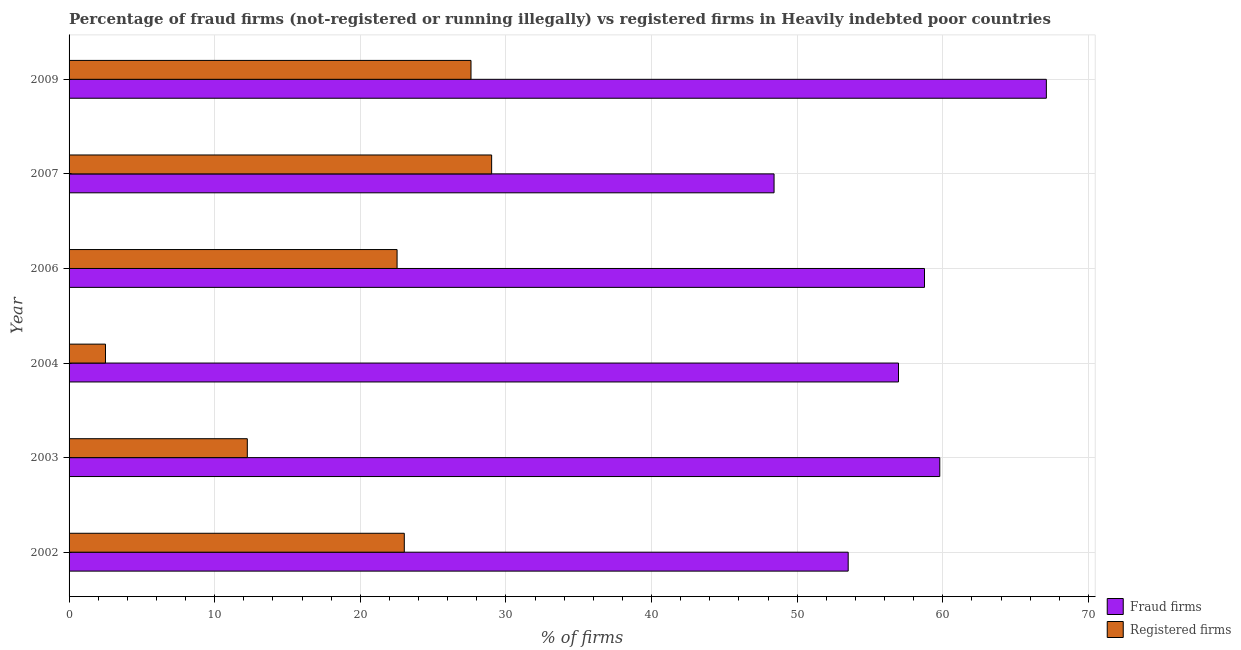How many groups of bars are there?
Offer a terse response. 6. How many bars are there on the 5th tick from the top?
Offer a very short reply. 2. How many bars are there on the 5th tick from the bottom?
Provide a succinct answer. 2. What is the label of the 3rd group of bars from the top?
Make the answer very short. 2006. What is the percentage of registered firms in 2007?
Keep it short and to the point. 29.02. Across all years, what is the maximum percentage of fraud firms?
Keep it short and to the point. 67.11. Across all years, what is the minimum percentage of fraud firms?
Keep it short and to the point. 48.41. What is the total percentage of fraud firms in the graph?
Your response must be concise. 344.5. What is the difference between the percentage of fraud firms in 2002 and that in 2003?
Offer a very short reply. -6.29. What is the difference between the percentage of fraud firms in 2002 and the percentage of registered firms in 2003?
Your answer should be very brief. 41.26. What is the average percentage of registered firms per year?
Provide a short and direct response. 19.48. In the year 2006, what is the difference between the percentage of registered firms and percentage of fraud firms?
Provide a short and direct response. -36.22. Is the percentage of registered firms in 2004 less than that in 2006?
Provide a succinct answer. Yes. What is the difference between the highest and the second highest percentage of registered firms?
Offer a terse response. 1.42. What is the difference between the highest and the lowest percentage of fraud firms?
Make the answer very short. 18.7. In how many years, is the percentage of fraud firms greater than the average percentage of fraud firms taken over all years?
Your answer should be compact. 3. What does the 2nd bar from the top in 2006 represents?
Give a very brief answer. Fraud firms. What does the 1st bar from the bottom in 2004 represents?
Ensure brevity in your answer.  Fraud firms. How many bars are there?
Give a very brief answer. 12. How many years are there in the graph?
Your answer should be very brief. 6. Are the values on the major ticks of X-axis written in scientific E-notation?
Your response must be concise. No. Does the graph contain any zero values?
Your answer should be compact. No. Does the graph contain grids?
Keep it short and to the point. Yes. How many legend labels are there?
Keep it short and to the point. 2. What is the title of the graph?
Offer a very short reply. Percentage of fraud firms (not-registered or running illegally) vs registered firms in Heavily indebted poor countries. What is the label or title of the X-axis?
Provide a succinct answer. % of firms. What is the label or title of the Y-axis?
Provide a short and direct response. Year. What is the % of firms in Fraud firms in 2002?
Offer a very short reply. 53.5. What is the % of firms in Registered firms in 2002?
Make the answer very short. 23.02. What is the % of firms of Fraud firms in 2003?
Ensure brevity in your answer.  59.79. What is the % of firms in Registered firms in 2003?
Your answer should be very brief. 12.24. What is the % of firms in Fraud firms in 2004?
Provide a succinct answer. 56.95. What is the % of firms in Fraud firms in 2006?
Your response must be concise. 58.74. What is the % of firms of Registered firms in 2006?
Give a very brief answer. 22.52. What is the % of firms of Fraud firms in 2007?
Offer a terse response. 48.41. What is the % of firms of Registered firms in 2007?
Your answer should be compact. 29.02. What is the % of firms in Fraud firms in 2009?
Your answer should be very brief. 67.11. What is the % of firms in Registered firms in 2009?
Your answer should be very brief. 27.6. Across all years, what is the maximum % of firms of Fraud firms?
Keep it short and to the point. 67.11. Across all years, what is the maximum % of firms of Registered firms?
Your answer should be compact. 29.02. Across all years, what is the minimum % of firms of Fraud firms?
Your answer should be compact. 48.41. What is the total % of firms of Fraud firms in the graph?
Your answer should be compact. 344.5. What is the total % of firms in Registered firms in the graph?
Offer a terse response. 116.9. What is the difference between the % of firms of Fraud firms in 2002 and that in 2003?
Keep it short and to the point. -6.29. What is the difference between the % of firms of Registered firms in 2002 and that in 2003?
Your response must be concise. 10.78. What is the difference between the % of firms of Fraud firms in 2002 and that in 2004?
Provide a short and direct response. -3.46. What is the difference between the % of firms in Registered firms in 2002 and that in 2004?
Make the answer very short. 20.52. What is the difference between the % of firms in Fraud firms in 2002 and that in 2006?
Your answer should be compact. -5.24. What is the difference between the % of firms of Registered firms in 2002 and that in 2006?
Give a very brief answer. 0.5. What is the difference between the % of firms in Fraud firms in 2002 and that in 2007?
Your response must be concise. 5.09. What is the difference between the % of firms of Registered firms in 2002 and that in 2007?
Provide a succinct answer. -6. What is the difference between the % of firms in Fraud firms in 2002 and that in 2009?
Provide a short and direct response. -13.61. What is the difference between the % of firms in Registered firms in 2002 and that in 2009?
Provide a short and direct response. -4.58. What is the difference between the % of firms of Fraud firms in 2003 and that in 2004?
Keep it short and to the point. 2.83. What is the difference between the % of firms of Registered firms in 2003 and that in 2004?
Provide a short and direct response. 9.74. What is the difference between the % of firms of Fraud firms in 2003 and that in 2006?
Ensure brevity in your answer.  1.05. What is the difference between the % of firms in Registered firms in 2003 and that in 2006?
Offer a terse response. -10.28. What is the difference between the % of firms of Fraud firms in 2003 and that in 2007?
Your answer should be compact. 11.38. What is the difference between the % of firms of Registered firms in 2003 and that in 2007?
Provide a succinct answer. -16.78. What is the difference between the % of firms of Fraud firms in 2003 and that in 2009?
Keep it short and to the point. -7.32. What is the difference between the % of firms of Registered firms in 2003 and that in 2009?
Your answer should be compact. -15.36. What is the difference between the % of firms in Fraud firms in 2004 and that in 2006?
Make the answer very short. -1.79. What is the difference between the % of firms in Registered firms in 2004 and that in 2006?
Provide a succinct answer. -20.02. What is the difference between the % of firms of Fraud firms in 2004 and that in 2007?
Provide a short and direct response. 8.54. What is the difference between the % of firms of Registered firms in 2004 and that in 2007?
Ensure brevity in your answer.  -26.52. What is the difference between the % of firms in Fraud firms in 2004 and that in 2009?
Your response must be concise. -10.15. What is the difference between the % of firms in Registered firms in 2004 and that in 2009?
Give a very brief answer. -25.1. What is the difference between the % of firms in Fraud firms in 2006 and that in 2007?
Your answer should be compact. 10.33. What is the difference between the % of firms in Registered firms in 2006 and that in 2007?
Offer a terse response. -6.49. What is the difference between the % of firms of Fraud firms in 2006 and that in 2009?
Offer a terse response. -8.37. What is the difference between the % of firms of Registered firms in 2006 and that in 2009?
Your answer should be compact. -5.08. What is the difference between the % of firms in Fraud firms in 2007 and that in 2009?
Provide a short and direct response. -18.7. What is the difference between the % of firms in Registered firms in 2007 and that in 2009?
Provide a succinct answer. 1.42. What is the difference between the % of firms of Fraud firms in 2002 and the % of firms of Registered firms in 2003?
Offer a terse response. 41.26. What is the difference between the % of firms of Fraud firms in 2002 and the % of firms of Registered firms in 2006?
Your response must be concise. 30.98. What is the difference between the % of firms of Fraud firms in 2002 and the % of firms of Registered firms in 2007?
Your answer should be very brief. 24.48. What is the difference between the % of firms of Fraud firms in 2002 and the % of firms of Registered firms in 2009?
Your answer should be compact. 25.9. What is the difference between the % of firms in Fraud firms in 2003 and the % of firms in Registered firms in 2004?
Make the answer very short. 57.29. What is the difference between the % of firms in Fraud firms in 2003 and the % of firms in Registered firms in 2006?
Give a very brief answer. 37.27. What is the difference between the % of firms in Fraud firms in 2003 and the % of firms in Registered firms in 2007?
Ensure brevity in your answer.  30.77. What is the difference between the % of firms in Fraud firms in 2003 and the % of firms in Registered firms in 2009?
Ensure brevity in your answer.  32.19. What is the difference between the % of firms of Fraud firms in 2004 and the % of firms of Registered firms in 2006?
Offer a terse response. 34.43. What is the difference between the % of firms in Fraud firms in 2004 and the % of firms in Registered firms in 2007?
Offer a very short reply. 27.94. What is the difference between the % of firms in Fraud firms in 2004 and the % of firms in Registered firms in 2009?
Offer a very short reply. 29.36. What is the difference between the % of firms of Fraud firms in 2006 and the % of firms of Registered firms in 2007?
Provide a succinct answer. 29.72. What is the difference between the % of firms in Fraud firms in 2006 and the % of firms in Registered firms in 2009?
Your answer should be very brief. 31.14. What is the difference between the % of firms in Fraud firms in 2007 and the % of firms in Registered firms in 2009?
Give a very brief answer. 20.81. What is the average % of firms in Fraud firms per year?
Provide a short and direct response. 57.42. What is the average % of firms in Registered firms per year?
Offer a very short reply. 19.48. In the year 2002, what is the difference between the % of firms in Fraud firms and % of firms in Registered firms?
Your answer should be compact. 30.48. In the year 2003, what is the difference between the % of firms in Fraud firms and % of firms in Registered firms?
Provide a succinct answer. 47.55. In the year 2004, what is the difference between the % of firms in Fraud firms and % of firms in Registered firms?
Keep it short and to the point. 54.45. In the year 2006, what is the difference between the % of firms in Fraud firms and % of firms in Registered firms?
Your response must be concise. 36.22. In the year 2007, what is the difference between the % of firms of Fraud firms and % of firms of Registered firms?
Provide a short and direct response. 19.39. In the year 2009, what is the difference between the % of firms in Fraud firms and % of firms in Registered firms?
Offer a terse response. 39.51. What is the ratio of the % of firms of Fraud firms in 2002 to that in 2003?
Keep it short and to the point. 0.89. What is the ratio of the % of firms of Registered firms in 2002 to that in 2003?
Make the answer very short. 1.88. What is the ratio of the % of firms of Fraud firms in 2002 to that in 2004?
Offer a very short reply. 0.94. What is the ratio of the % of firms in Registered firms in 2002 to that in 2004?
Your answer should be very brief. 9.21. What is the ratio of the % of firms in Fraud firms in 2002 to that in 2006?
Offer a very short reply. 0.91. What is the ratio of the % of firms of Registered firms in 2002 to that in 2006?
Provide a short and direct response. 1.02. What is the ratio of the % of firms of Fraud firms in 2002 to that in 2007?
Ensure brevity in your answer.  1.11. What is the ratio of the % of firms in Registered firms in 2002 to that in 2007?
Keep it short and to the point. 0.79. What is the ratio of the % of firms of Fraud firms in 2002 to that in 2009?
Provide a short and direct response. 0.8. What is the ratio of the % of firms in Registered firms in 2002 to that in 2009?
Provide a succinct answer. 0.83. What is the ratio of the % of firms of Fraud firms in 2003 to that in 2004?
Keep it short and to the point. 1.05. What is the ratio of the % of firms in Registered firms in 2003 to that in 2004?
Make the answer very short. 4.9. What is the ratio of the % of firms of Fraud firms in 2003 to that in 2006?
Offer a very short reply. 1.02. What is the ratio of the % of firms of Registered firms in 2003 to that in 2006?
Keep it short and to the point. 0.54. What is the ratio of the % of firms in Fraud firms in 2003 to that in 2007?
Your answer should be very brief. 1.24. What is the ratio of the % of firms in Registered firms in 2003 to that in 2007?
Offer a very short reply. 0.42. What is the ratio of the % of firms in Fraud firms in 2003 to that in 2009?
Keep it short and to the point. 0.89. What is the ratio of the % of firms of Registered firms in 2003 to that in 2009?
Ensure brevity in your answer.  0.44. What is the ratio of the % of firms in Fraud firms in 2004 to that in 2006?
Offer a very short reply. 0.97. What is the ratio of the % of firms in Registered firms in 2004 to that in 2006?
Make the answer very short. 0.11. What is the ratio of the % of firms in Fraud firms in 2004 to that in 2007?
Your answer should be very brief. 1.18. What is the ratio of the % of firms of Registered firms in 2004 to that in 2007?
Offer a very short reply. 0.09. What is the ratio of the % of firms in Fraud firms in 2004 to that in 2009?
Provide a short and direct response. 0.85. What is the ratio of the % of firms of Registered firms in 2004 to that in 2009?
Offer a very short reply. 0.09. What is the ratio of the % of firms of Fraud firms in 2006 to that in 2007?
Offer a terse response. 1.21. What is the ratio of the % of firms in Registered firms in 2006 to that in 2007?
Your answer should be very brief. 0.78. What is the ratio of the % of firms in Fraud firms in 2006 to that in 2009?
Offer a terse response. 0.88. What is the ratio of the % of firms in Registered firms in 2006 to that in 2009?
Offer a terse response. 0.82. What is the ratio of the % of firms of Fraud firms in 2007 to that in 2009?
Ensure brevity in your answer.  0.72. What is the ratio of the % of firms of Registered firms in 2007 to that in 2009?
Your answer should be compact. 1.05. What is the difference between the highest and the second highest % of firms in Fraud firms?
Your answer should be very brief. 7.32. What is the difference between the highest and the second highest % of firms of Registered firms?
Offer a terse response. 1.42. What is the difference between the highest and the lowest % of firms in Fraud firms?
Provide a short and direct response. 18.7. What is the difference between the highest and the lowest % of firms of Registered firms?
Your answer should be very brief. 26.52. 